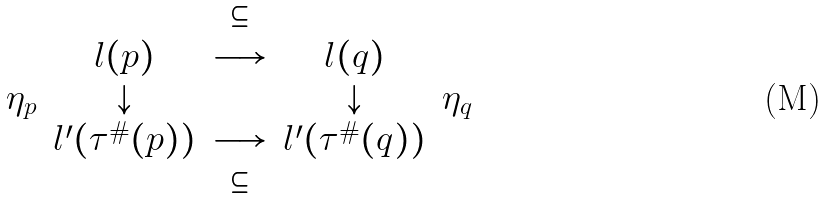Convert formula to latex. <formula><loc_0><loc_0><loc_500><loc_500>\begin{matrix} & & \subseteq & & \\ & l ( p ) & \longrightarrow & l ( q ) & \\ \eta _ { p } & \downarrow & & \downarrow & \eta _ { q } \\ & l ^ { \prime } ( \tau ^ { \# } ( p ) ) & \longrightarrow & l ^ { \prime } ( \tau ^ { \# } ( q ) ) & \\ & & \subseteq & & \end{matrix}</formula> 